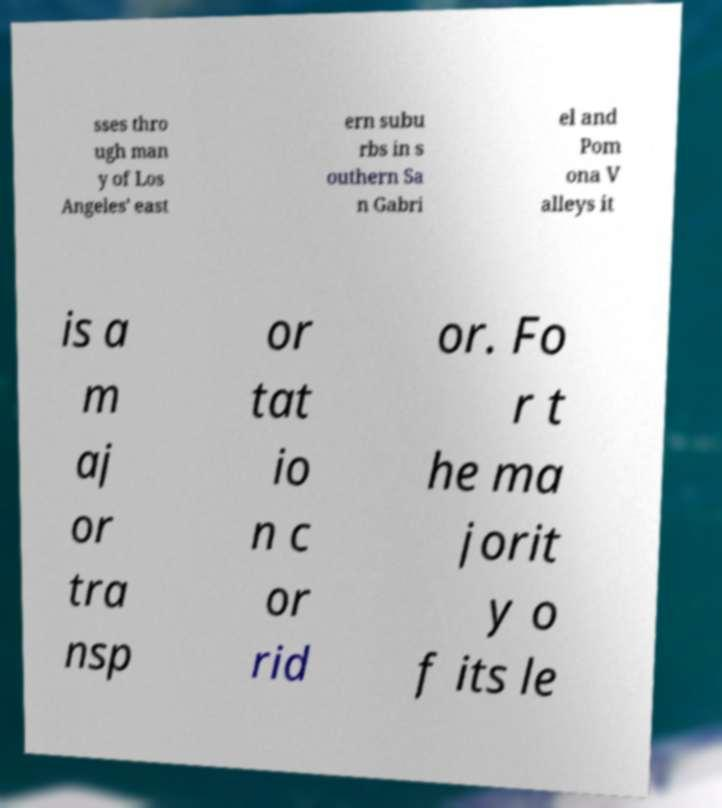I need the written content from this picture converted into text. Can you do that? sses thro ugh man y of Los Angeles' east ern subu rbs in s outhern Sa n Gabri el and Pom ona V alleys it is a m aj or tra nsp or tat io n c or rid or. Fo r t he ma jorit y o f its le 